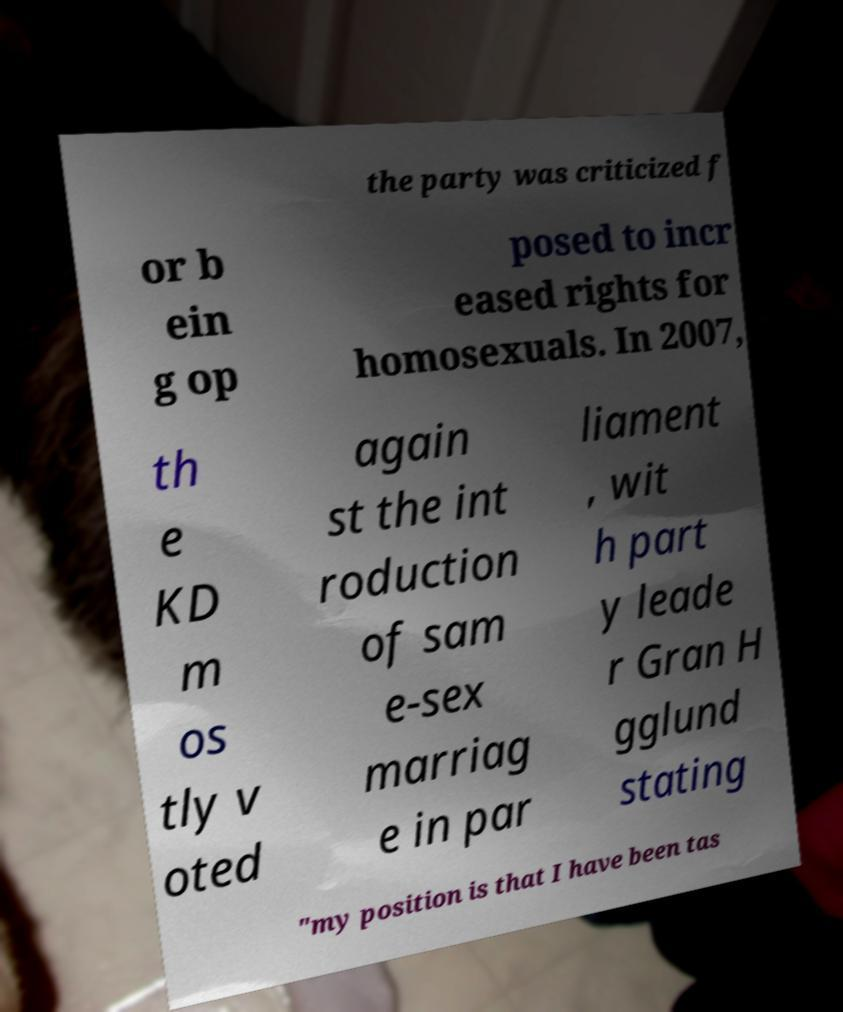For documentation purposes, I need the text within this image transcribed. Could you provide that? the party was criticized f or b ein g op posed to incr eased rights for homosexuals. In 2007, th e KD m os tly v oted again st the int roduction of sam e-sex marriag e in par liament , wit h part y leade r Gran H gglund stating "my position is that I have been tas 